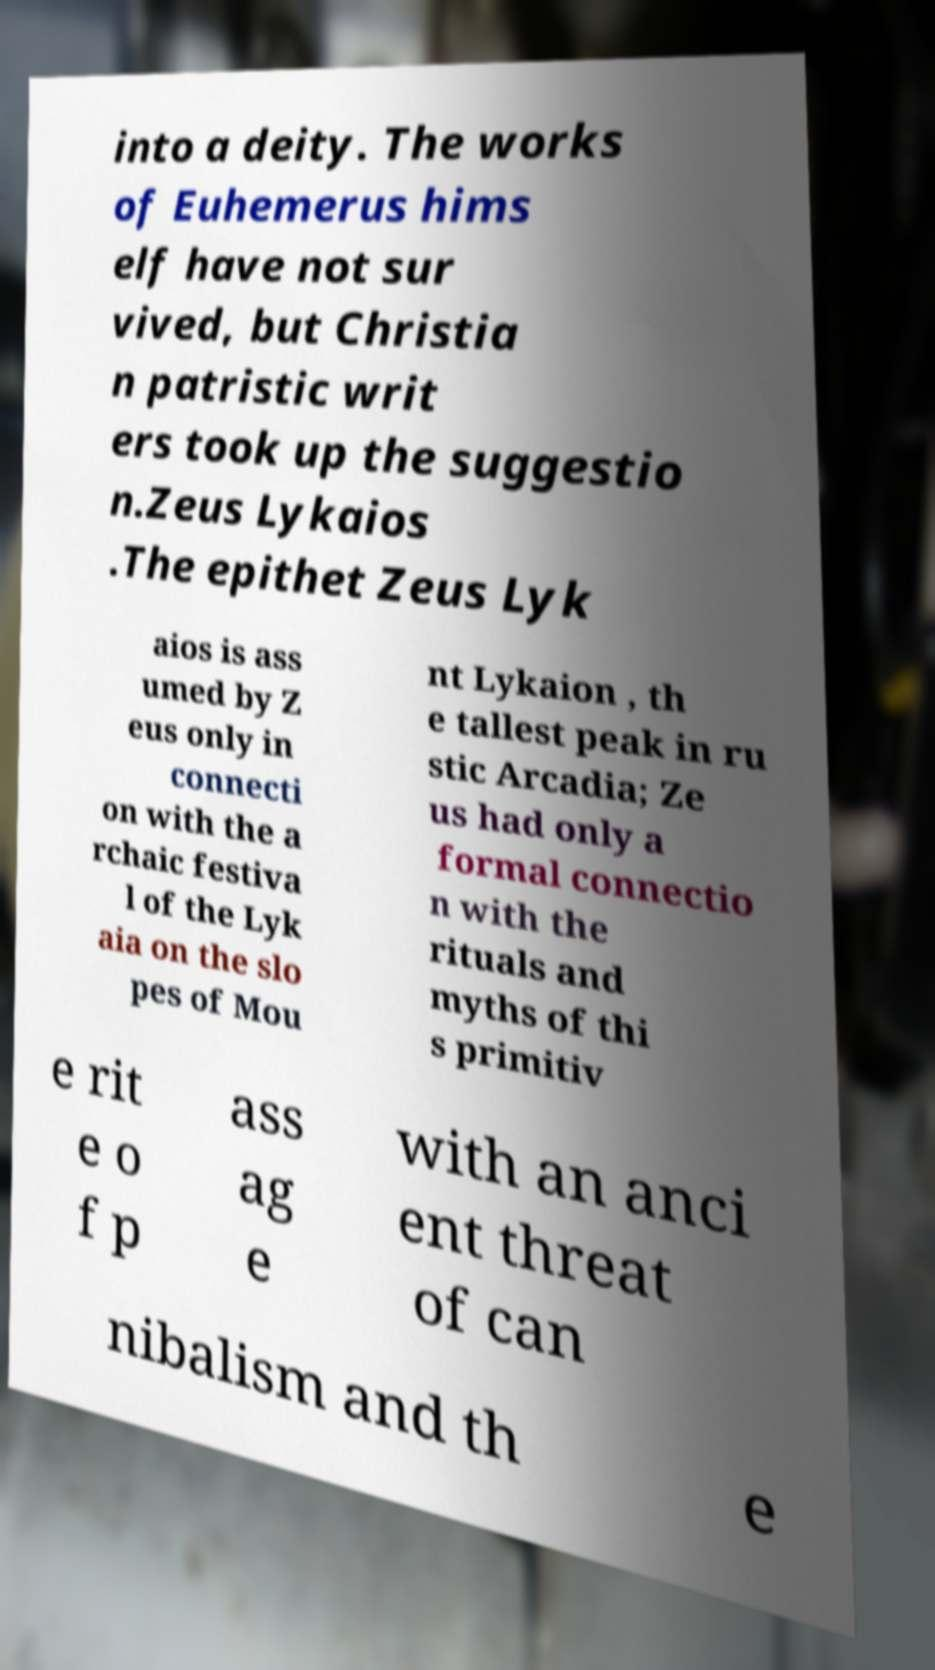Can you read and provide the text displayed in the image?This photo seems to have some interesting text. Can you extract and type it out for me? into a deity. The works of Euhemerus hims elf have not sur vived, but Christia n patristic writ ers took up the suggestio n.Zeus Lykaios .The epithet Zeus Lyk aios is ass umed by Z eus only in connecti on with the a rchaic festiva l of the Lyk aia on the slo pes of Mou nt Lykaion , th e tallest peak in ru stic Arcadia; Ze us had only a formal connectio n with the rituals and myths of thi s primitiv e rit e o f p ass ag e with an anci ent threat of can nibalism and th e 